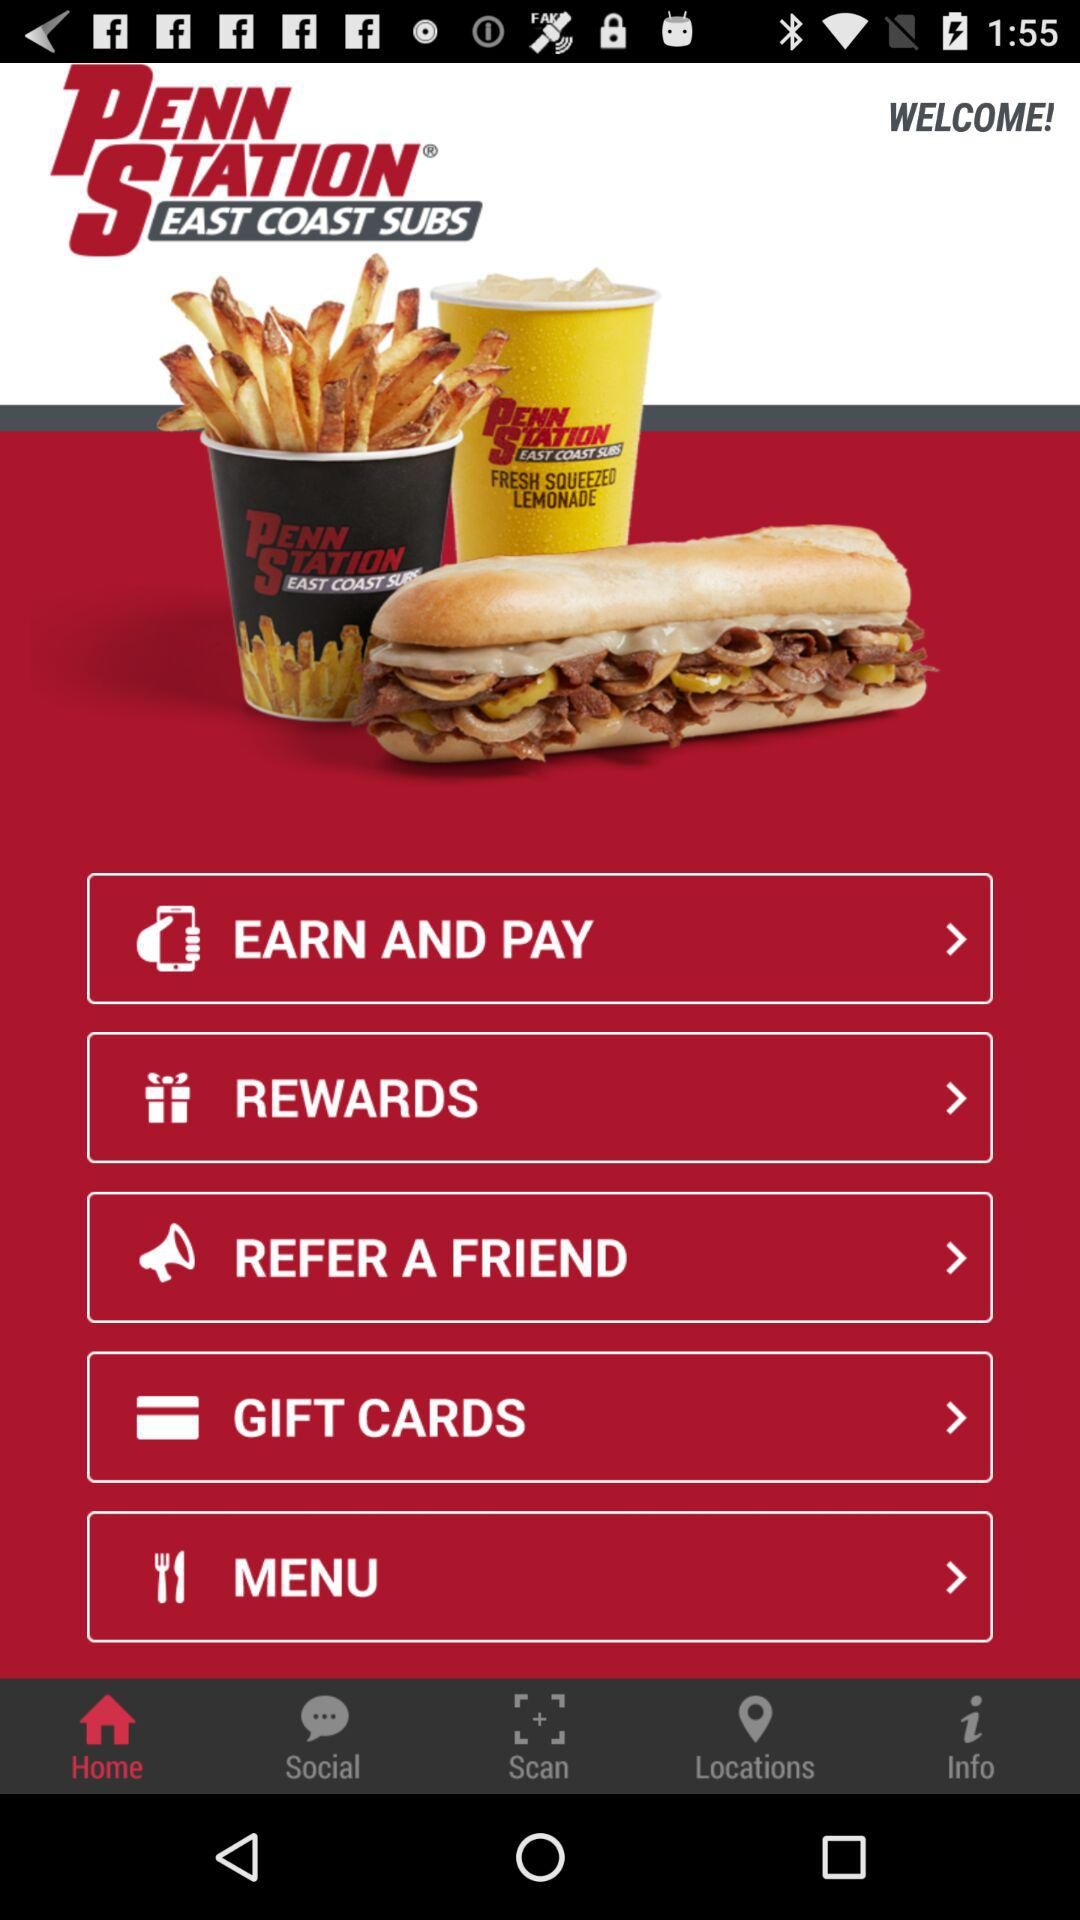Which tab is selected? The selected tab is "Home". 